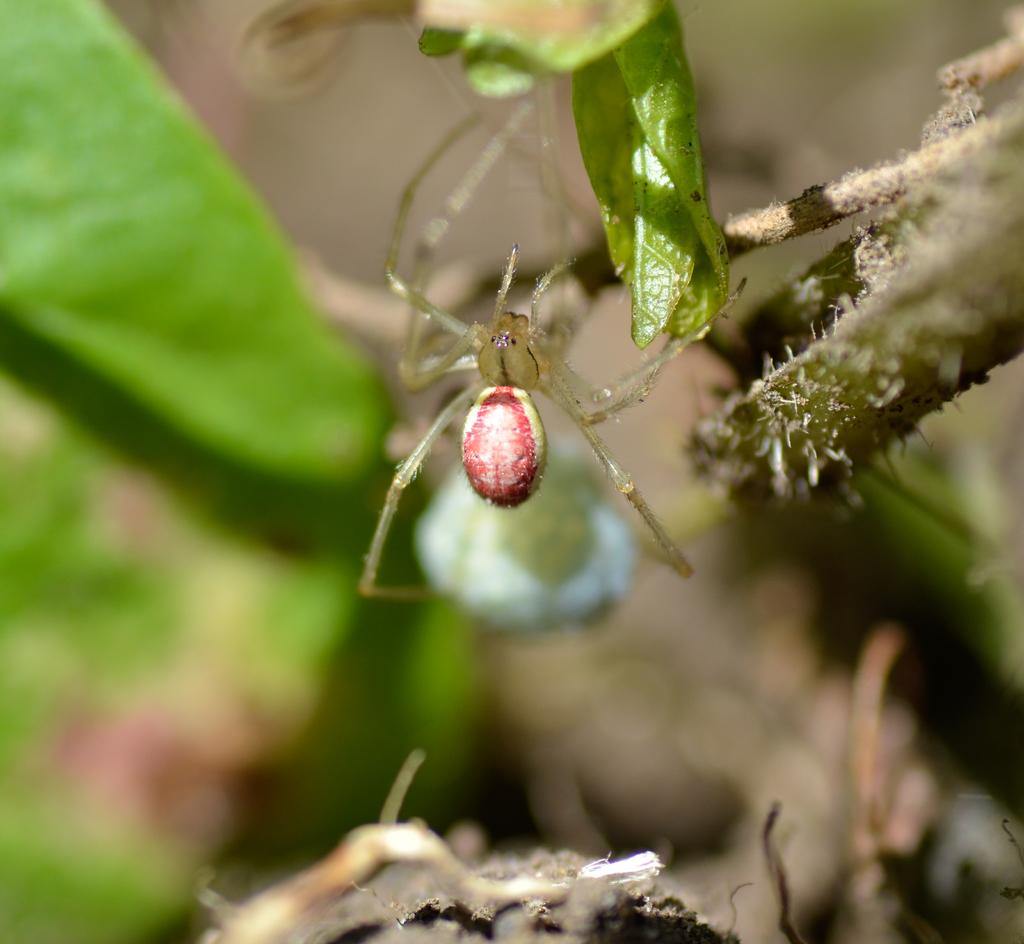What is present in the image? There is an insect in the image. Where is the insect located? The insect is on a green leaf. Can you describe the background of the image? The background of the image is blurred. What type of wood can be seen in the image? There is no wood present in the image; it features an insect on a green leaf with a blurred background. Can you describe the behavior of the rabbit in the image? There is no rabbit present in the image. 